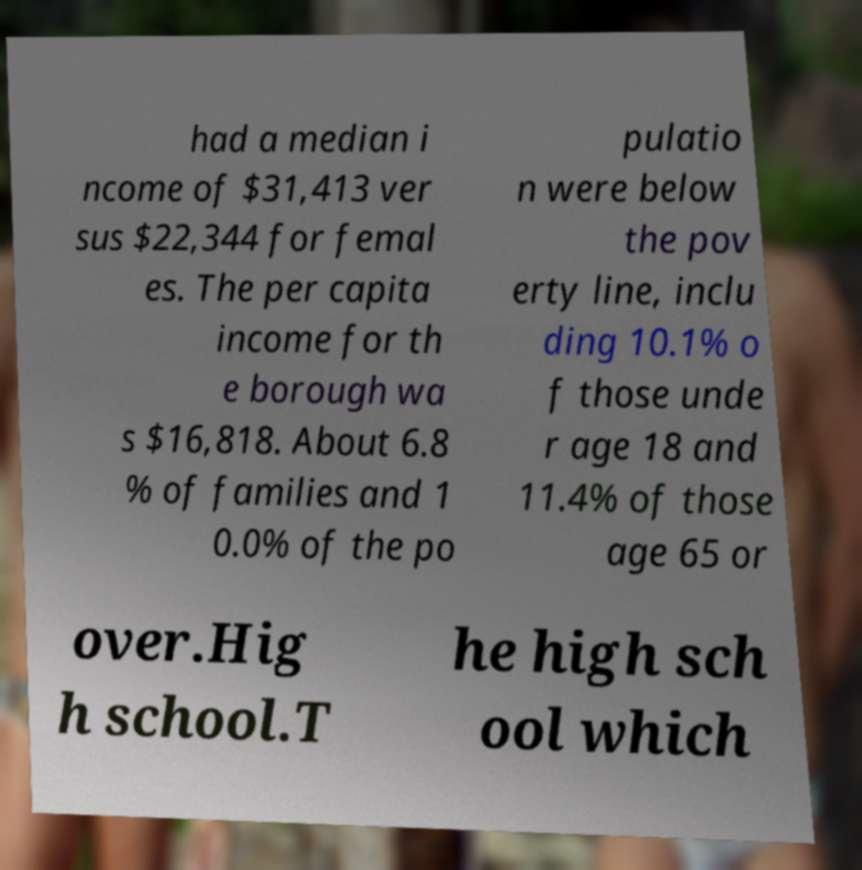For documentation purposes, I need the text within this image transcribed. Could you provide that? had a median i ncome of $31,413 ver sus $22,344 for femal es. The per capita income for th e borough wa s $16,818. About 6.8 % of families and 1 0.0% of the po pulatio n were below the pov erty line, inclu ding 10.1% o f those unde r age 18 and 11.4% of those age 65 or over.Hig h school.T he high sch ool which 